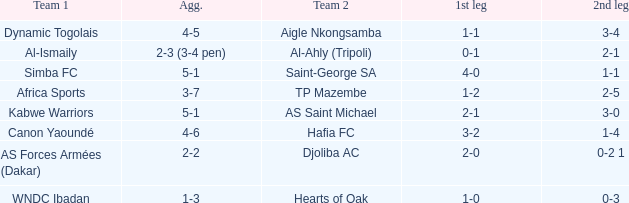What team played against Al-Ismaily (team 1)? Al-Ahly (Tripoli). 